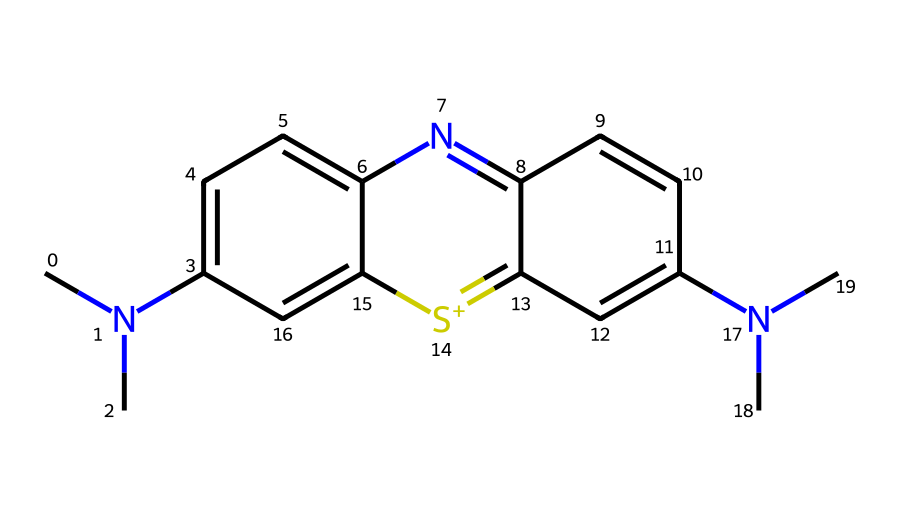What is the molecular formula of methylene blue? To determine the molecular formula, we can analyze the number of each type of atom represented in the SMILES notation. There are 16 Carbon (C) atoms, 18 Hydrogen (H) atoms, 3 Nitrogen (N) atoms, and 1 Sulfur (S) atom. Putting these together gives us C16H18N3S.
Answer: C16H18N3S How many nitrogen atoms are present in the structure? The SMILES notation includes 3 'N' atoms which represent the nitrogen atoms in the molecule.
Answer: 3 What type of bonding is primarily seen in methylene blue? The structure contains multiple aromatic rings and connection points suggest that there are significant pi-conjugation systems, indicating resonance bonding among the aromatic carbons.
Answer: resonance Which feature of methylene blue contributes to its usage in staining? The presence of nitrogen atoms in the structure allows it to form positive charges which can bind to biological tissues, making it suitable for staining.
Answer: positive charge What physical state is methylene blue typically found in? Methylene blue is commonly found as a solid or powder at room temperature; its structure stable allows it to maintain this state.
Answer: solid How is methylene blue classified in terms of its application? Methylene blue acts as a dye that is used both in biological contexts and therapeutic applications. This dual role underscores its versatility.
Answer: dye What is the significance of the sulfur atom in the dye? The sulfur atom presents a characteristic feature in some aromatic dyes, potentially aiding in electron delocalization and contributing to the dye's color properties, indicating its role in the absorbing spectrum.
Answer: color properties 